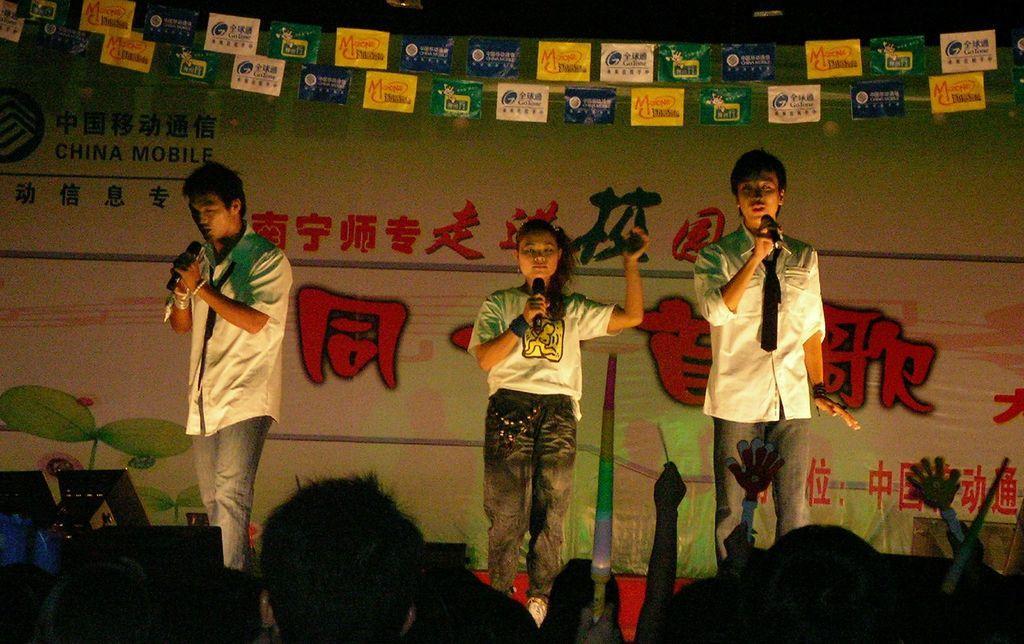Describe this image in one or two sentences. This picture describe about the two boy wearing white color shirt holding microphone in the hand and singing on the stage. In the middle we can see a girl wearing white color t- shirt and black jeans holding a microphone in the head. Behind we can see white background banner with some quotes written in Chinese language. Above we can see some blue, yellow and white color flag. In front bottom side we can see group of people sitting and watching to them. 